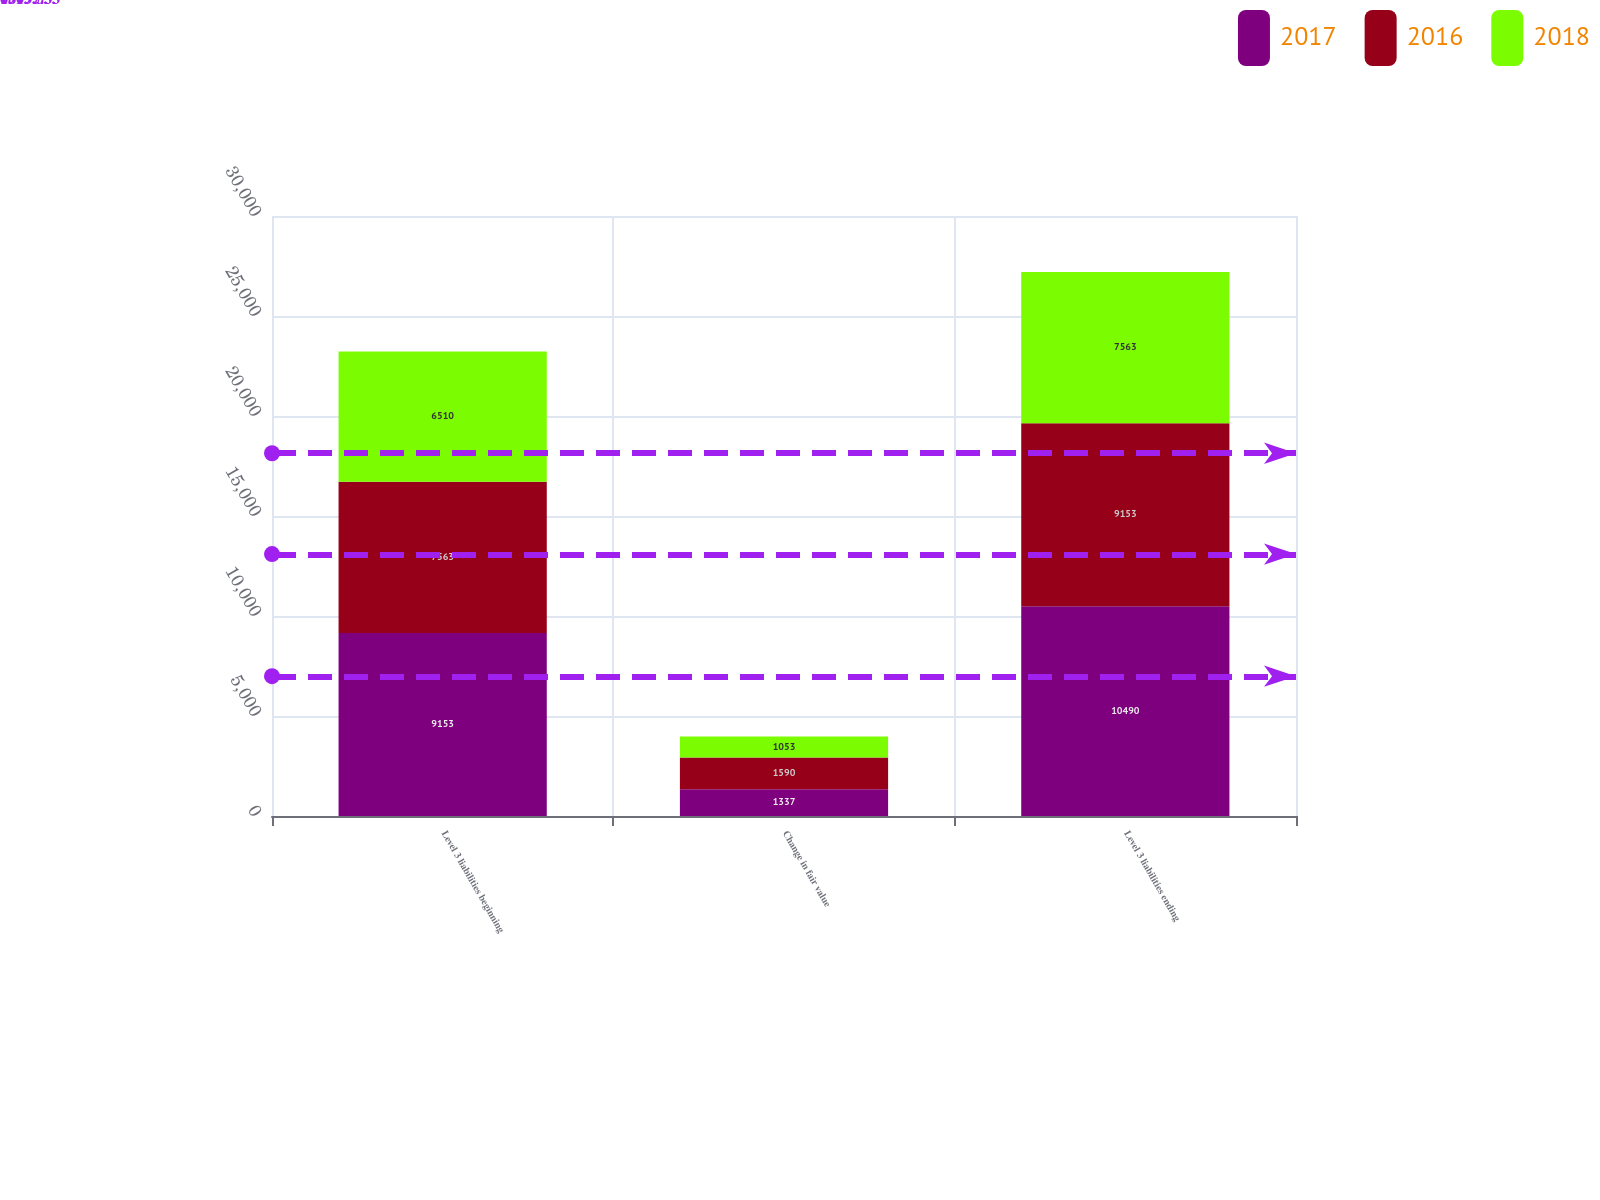<chart> <loc_0><loc_0><loc_500><loc_500><stacked_bar_chart><ecel><fcel>Level 3 liabilities beginning<fcel>Change in fair value<fcel>Level 3 liabilities ending<nl><fcel>2017<fcel>9153<fcel>1337<fcel>10490<nl><fcel>2016<fcel>7563<fcel>1590<fcel>9153<nl><fcel>2018<fcel>6510<fcel>1053<fcel>7563<nl></chart> 